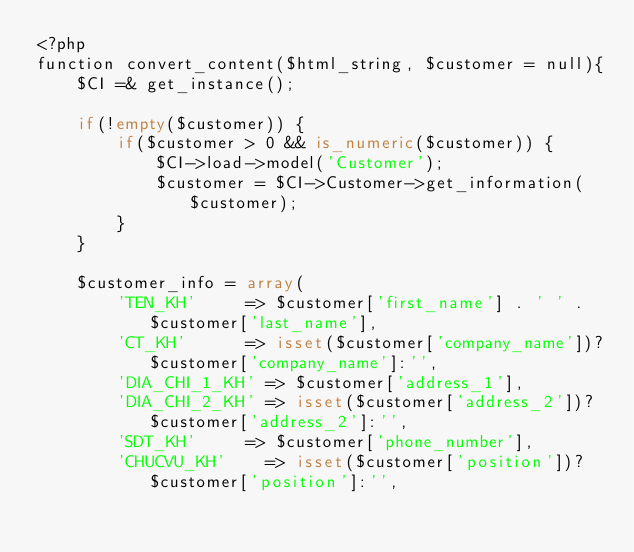<code> <loc_0><loc_0><loc_500><loc_500><_PHP_><?php
function convert_content($html_string, $customer = null){
    $CI =& get_instance();

    if(!empty($customer)) {
        if($customer > 0 && is_numeric($customer)) {
            $CI->load->model('Customer');
            $customer = $CI->Customer->get_information($customer);
        }
    }

    $customer_info = array(
        'TEN_KH' 	   => $customer['first_name'] . ' ' . $customer['last_name'],
        'CT_KH' 	   => isset($customer['company_name'])?$customer['company_name']:'',
        'DIA_CHI_1_KH' => $customer['address_1'],
        'DIA_CHI_2_KH' => isset($customer['address_2'])?$customer['address_2']:'',
        'SDT_KH' 	   => $customer['phone_number'],
   		  'CHUCVU_KH'    => isset($customer['position'])?$customer['position']:'',</code> 